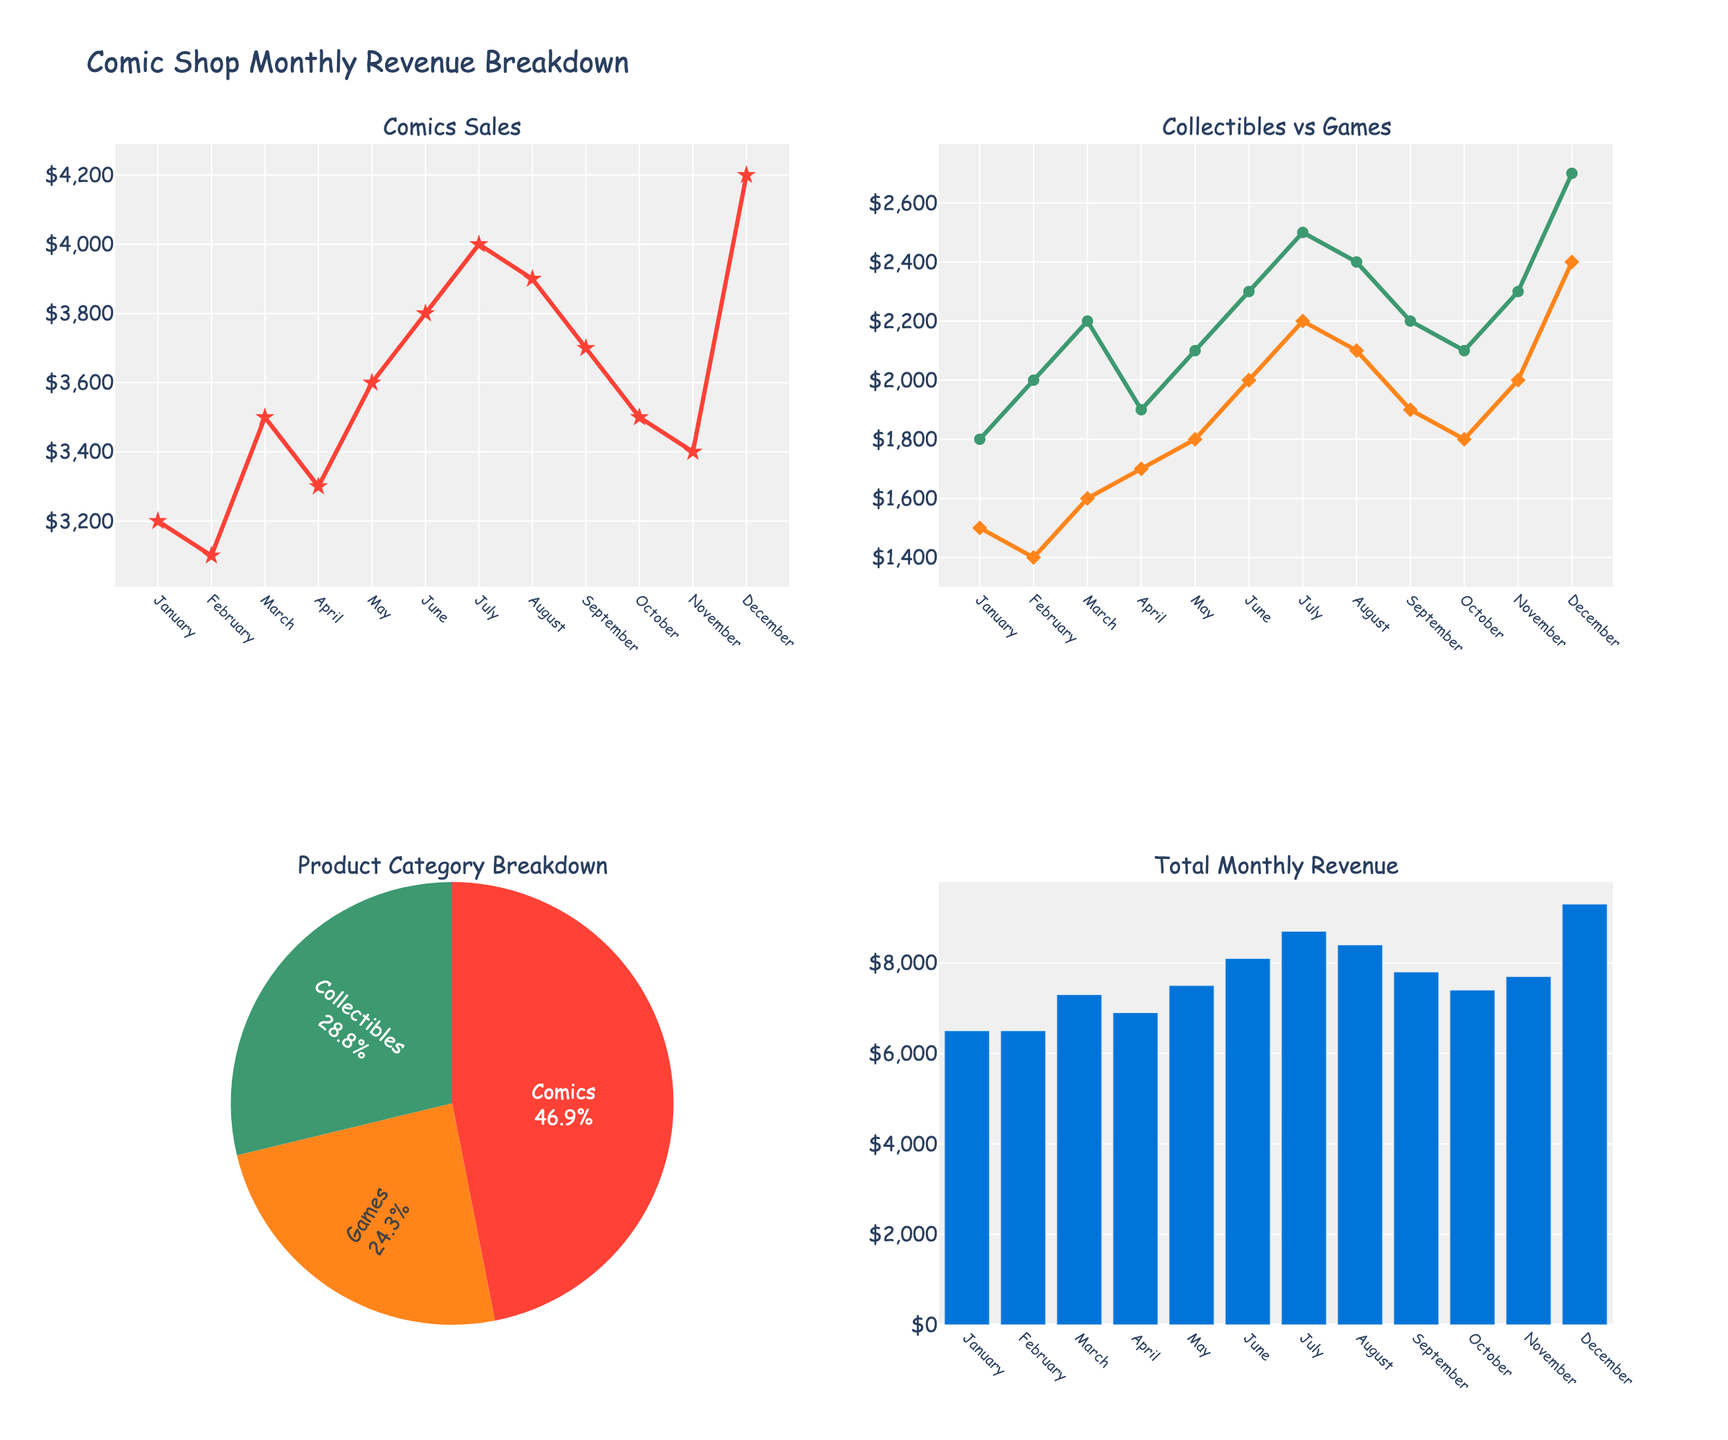What is the title of the figure? The title is typically displayed at the top of the chart to provide an overview of what the figure represents. In this case, it likely specifies the demographic breakdown of military personnel.
Answer: Demographic Breakdown of Military Personnel Which country shows the highest percentage of military personnel aged 18-24 with a Bachelor's degree? To find this, locate the 18-24 age group and look for the highest bar among all the subplots for personnel with a Bachelor's degree. This involves checking the hover information for the education level across countries.
Answer: USA How does the percentage of male military personnel aged 25-34 in the UK compare to those in Germany? Look at the bars representing males aged 25-34 in both the UK and Germany subplots. Compare the heights and percentages directly from the chart annotations.
Answer: UK: 18%, Germany: 17% What is the combined percentage of male and female military personnel aged 35-44 with a Master's degree in France? Identify the bars for male and female personnel aged 35-44 in the France subplot. Sum the percentages of both to get the combined value.
Answer: 4% Which gender has a higher percentage among military personnel aged 18-24 with high school equivalency (A-Levels, Baccalauréat, Abitur) in the figure? Check the 18-24 age group bars for all countries and compare the male and female percentages for the given education levels.
Answer: Male Is there any age group where females have a higher percentage than males in military personnel across all countries? Examine each age group's bars for every country to determine whether any female percentage bar is higher than the corresponding male bar.
Answer: No What's the average percentage of military personnel aged 25-34 with a Bachelor's degree across all countries? Calculate the mean percentage by adding the percentages for the 25-34 age group with a Bachelor's degree from each country and dividing by the number of countries. USA: 20%, UK: 18%, France: 16%, Germany: 17%. (20 + 18 + 16 + 17) / 4 = 17.75
Answer: 17.75% Which country has the smallest percentage of female military personnel with a Master's degree? Review the subplot for the smallest female percentage bar in the 35-44 age group with a Master's degree. Compare percentages for the USA, UK, France, and Germany.
Answer: UK How does the percentage of male military personnel aged 18-24 in Germany compare to those in the USA? Compare the heights and percentages of the 18-24 age group bars for males in the Germany and USA subplots.
Answer: USA: 30%, Germany: 24% 